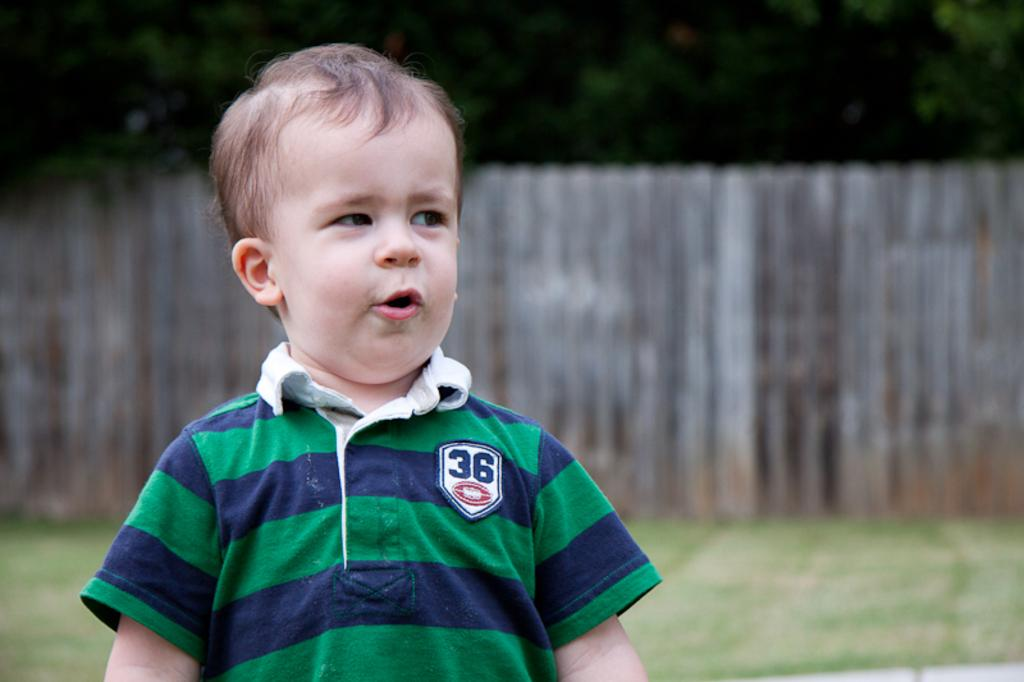<image>
Relay a brief, clear account of the picture shown. A baby has the numbers 36 on his colorful shirt while he stands near a fence 